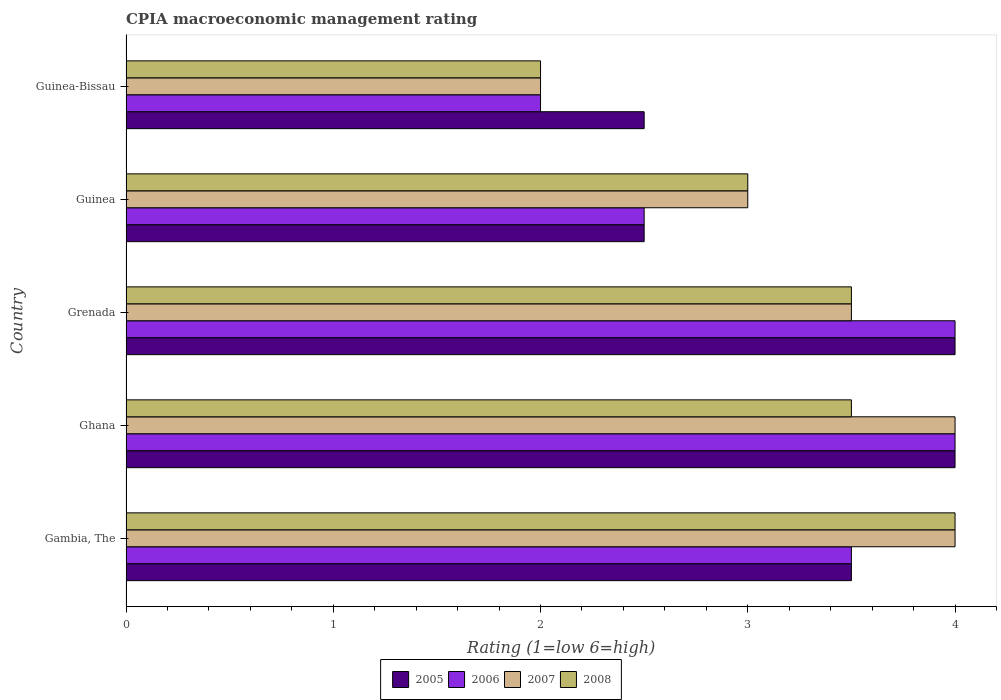How many groups of bars are there?
Give a very brief answer. 5. How many bars are there on the 4th tick from the top?
Your response must be concise. 4. What is the label of the 2nd group of bars from the top?
Give a very brief answer. Guinea. Across all countries, what is the maximum CPIA rating in 2008?
Keep it short and to the point. 4. In which country was the CPIA rating in 2005 minimum?
Ensure brevity in your answer.  Guinea. What is the total CPIA rating in 2005 in the graph?
Provide a succinct answer. 16.5. What is the difference between the CPIA rating in 2005 in Gambia, The and that in Grenada?
Your answer should be compact. -0.5. What is the difference between the CPIA rating in 2005 in Guinea and the CPIA rating in 2007 in Grenada?
Make the answer very short. -1. What is the average CPIA rating in 2006 per country?
Provide a succinct answer. 3.2. What is the difference between the CPIA rating in 2005 and CPIA rating in 2007 in Guinea-Bissau?
Provide a succinct answer. 0.5. What is the ratio of the CPIA rating in 2005 in Ghana to that in Guinea-Bissau?
Ensure brevity in your answer.  1.6. Is the difference between the CPIA rating in 2005 in Gambia, The and Guinea greater than the difference between the CPIA rating in 2007 in Gambia, The and Guinea?
Offer a terse response. No. What does the 2nd bar from the bottom in Ghana represents?
Your response must be concise. 2006. Is it the case that in every country, the sum of the CPIA rating in 2005 and CPIA rating in 2008 is greater than the CPIA rating in 2006?
Make the answer very short. Yes. Are the values on the major ticks of X-axis written in scientific E-notation?
Your response must be concise. No. Does the graph contain any zero values?
Your answer should be compact. No. Does the graph contain grids?
Provide a succinct answer. No. Where does the legend appear in the graph?
Your response must be concise. Bottom center. How many legend labels are there?
Provide a short and direct response. 4. How are the legend labels stacked?
Your answer should be very brief. Horizontal. What is the title of the graph?
Your answer should be compact. CPIA macroeconomic management rating. What is the label or title of the X-axis?
Your response must be concise. Rating (1=low 6=high). What is the label or title of the Y-axis?
Your response must be concise. Country. What is the Rating (1=low 6=high) in 2005 in Gambia, The?
Offer a very short reply. 3.5. What is the Rating (1=low 6=high) in 2005 in Ghana?
Provide a succinct answer. 4. What is the Rating (1=low 6=high) of 2006 in Ghana?
Make the answer very short. 4. What is the Rating (1=low 6=high) of 2007 in Ghana?
Provide a short and direct response. 4. What is the Rating (1=low 6=high) in 2008 in Ghana?
Keep it short and to the point. 3.5. What is the Rating (1=low 6=high) of 2008 in Grenada?
Offer a terse response. 3.5. What is the Rating (1=low 6=high) of 2005 in Guinea?
Provide a short and direct response. 2.5. What is the Rating (1=low 6=high) in 2006 in Guinea?
Give a very brief answer. 2.5. What is the Rating (1=low 6=high) of 2008 in Guinea?
Keep it short and to the point. 3. What is the Rating (1=low 6=high) of 2008 in Guinea-Bissau?
Give a very brief answer. 2. Across all countries, what is the maximum Rating (1=low 6=high) in 2005?
Provide a succinct answer. 4. Across all countries, what is the maximum Rating (1=low 6=high) of 2006?
Keep it short and to the point. 4. Across all countries, what is the maximum Rating (1=low 6=high) in 2007?
Make the answer very short. 4. Across all countries, what is the maximum Rating (1=low 6=high) of 2008?
Your response must be concise. 4. Across all countries, what is the minimum Rating (1=low 6=high) of 2005?
Ensure brevity in your answer.  2.5. Across all countries, what is the minimum Rating (1=low 6=high) in 2008?
Provide a succinct answer. 2. What is the total Rating (1=low 6=high) of 2007 in the graph?
Your response must be concise. 16.5. What is the total Rating (1=low 6=high) of 2008 in the graph?
Offer a very short reply. 16. What is the difference between the Rating (1=low 6=high) in 2005 in Gambia, The and that in Ghana?
Your answer should be compact. -0.5. What is the difference between the Rating (1=low 6=high) of 2006 in Gambia, The and that in Ghana?
Provide a short and direct response. -0.5. What is the difference between the Rating (1=low 6=high) of 2008 in Gambia, The and that in Ghana?
Your answer should be very brief. 0.5. What is the difference between the Rating (1=low 6=high) of 2005 in Gambia, The and that in Grenada?
Your answer should be very brief. -0.5. What is the difference between the Rating (1=low 6=high) in 2008 in Gambia, The and that in Guinea?
Provide a short and direct response. 1. What is the difference between the Rating (1=low 6=high) of 2005 in Gambia, The and that in Guinea-Bissau?
Make the answer very short. 1. What is the difference between the Rating (1=low 6=high) in 2007 in Gambia, The and that in Guinea-Bissau?
Your response must be concise. 2. What is the difference between the Rating (1=low 6=high) in 2005 in Ghana and that in Guinea?
Your answer should be compact. 1.5. What is the difference between the Rating (1=low 6=high) in 2006 in Ghana and that in Guinea-Bissau?
Give a very brief answer. 2. What is the difference between the Rating (1=low 6=high) in 2005 in Grenada and that in Guinea?
Provide a short and direct response. 1.5. What is the difference between the Rating (1=low 6=high) of 2005 in Guinea and that in Guinea-Bissau?
Provide a short and direct response. 0. What is the difference between the Rating (1=low 6=high) in 2008 in Guinea and that in Guinea-Bissau?
Give a very brief answer. 1. What is the difference between the Rating (1=low 6=high) of 2005 in Gambia, The and the Rating (1=low 6=high) of 2008 in Ghana?
Give a very brief answer. 0. What is the difference between the Rating (1=low 6=high) in 2007 in Gambia, The and the Rating (1=low 6=high) in 2008 in Ghana?
Provide a short and direct response. 0.5. What is the difference between the Rating (1=low 6=high) in 2005 in Gambia, The and the Rating (1=low 6=high) in 2006 in Grenada?
Give a very brief answer. -0.5. What is the difference between the Rating (1=low 6=high) of 2006 in Gambia, The and the Rating (1=low 6=high) of 2007 in Grenada?
Your answer should be compact. 0. What is the difference between the Rating (1=low 6=high) of 2006 in Gambia, The and the Rating (1=low 6=high) of 2008 in Grenada?
Keep it short and to the point. 0. What is the difference between the Rating (1=low 6=high) in 2005 in Gambia, The and the Rating (1=low 6=high) in 2006 in Guinea?
Offer a very short reply. 1. What is the difference between the Rating (1=low 6=high) of 2005 in Gambia, The and the Rating (1=low 6=high) of 2008 in Guinea?
Make the answer very short. 0.5. What is the difference between the Rating (1=low 6=high) in 2005 in Gambia, The and the Rating (1=low 6=high) in 2007 in Guinea-Bissau?
Your response must be concise. 1.5. What is the difference between the Rating (1=low 6=high) of 2005 in Gambia, The and the Rating (1=low 6=high) of 2008 in Guinea-Bissau?
Keep it short and to the point. 1.5. What is the difference between the Rating (1=low 6=high) in 2006 in Gambia, The and the Rating (1=low 6=high) in 2007 in Guinea-Bissau?
Provide a succinct answer. 1.5. What is the difference between the Rating (1=low 6=high) of 2006 in Gambia, The and the Rating (1=low 6=high) of 2008 in Guinea-Bissau?
Provide a succinct answer. 1.5. What is the difference between the Rating (1=low 6=high) in 2007 in Gambia, The and the Rating (1=low 6=high) in 2008 in Guinea-Bissau?
Keep it short and to the point. 2. What is the difference between the Rating (1=low 6=high) of 2005 in Ghana and the Rating (1=low 6=high) of 2006 in Grenada?
Offer a very short reply. 0. What is the difference between the Rating (1=low 6=high) in 2005 in Ghana and the Rating (1=low 6=high) in 2008 in Grenada?
Your answer should be very brief. 0.5. What is the difference between the Rating (1=low 6=high) in 2006 in Ghana and the Rating (1=low 6=high) in 2007 in Grenada?
Make the answer very short. 0.5. What is the difference between the Rating (1=low 6=high) of 2006 in Ghana and the Rating (1=low 6=high) of 2008 in Grenada?
Give a very brief answer. 0.5. What is the difference between the Rating (1=low 6=high) of 2007 in Ghana and the Rating (1=low 6=high) of 2008 in Grenada?
Offer a terse response. 0.5. What is the difference between the Rating (1=low 6=high) in 2006 in Ghana and the Rating (1=low 6=high) in 2007 in Guinea?
Offer a terse response. 1. What is the difference between the Rating (1=low 6=high) of 2005 in Ghana and the Rating (1=low 6=high) of 2006 in Guinea-Bissau?
Your answer should be compact. 2. What is the difference between the Rating (1=low 6=high) in 2005 in Ghana and the Rating (1=low 6=high) in 2008 in Guinea-Bissau?
Ensure brevity in your answer.  2. What is the difference between the Rating (1=low 6=high) of 2006 in Ghana and the Rating (1=low 6=high) of 2007 in Guinea-Bissau?
Give a very brief answer. 2. What is the difference between the Rating (1=low 6=high) in 2006 in Ghana and the Rating (1=low 6=high) in 2008 in Guinea-Bissau?
Keep it short and to the point. 2. What is the difference between the Rating (1=low 6=high) in 2007 in Ghana and the Rating (1=low 6=high) in 2008 in Guinea-Bissau?
Your answer should be compact. 2. What is the difference between the Rating (1=low 6=high) of 2005 in Grenada and the Rating (1=low 6=high) of 2006 in Guinea?
Your answer should be compact. 1.5. What is the difference between the Rating (1=low 6=high) of 2005 in Grenada and the Rating (1=low 6=high) of 2007 in Guinea?
Your answer should be compact. 1. What is the difference between the Rating (1=low 6=high) in 2007 in Grenada and the Rating (1=low 6=high) in 2008 in Guinea?
Your answer should be compact. 0.5. What is the difference between the Rating (1=low 6=high) in 2005 in Grenada and the Rating (1=low 6=high) in 2006 in Guinea-Bissau?
Your response must be concise. 2. What is the difference between the Rating (1=low 6=high) in 2005 in Grenada and the Rating (1=low 6=high) in 2007 in Guinea-Bissau?
Your answer should be compact. 2. What is the difference between the Rating (1=low 6=high) in 2005 in Grenada and the Rating (1=low 6=high) in 2008 in Guinea-Bissau?
Your answer should be compact. 2. What is the difference between the Rating (1=low 6=high) of 2006 in Grenada and the Rating (1=low 6=high) of 2007 in Guinea-Bissau?
Your response must be concise. 2. What is the difference between the Rating (1=low 6=high) in 2007 in Grenada and the Rating (1=low 6=high) in 2008 in Guinea-Bissau?
Your answer should be very brief. 1.5. What is the difference between the Rating (1=low 6=high) of 2005 in Guinea and the Rating (1=low 6=high) of 2006 in Guinea-Bissau?
Ensure brevity in your answer.  0.5. What is the difference between the Rating (1=low 6=high) in 2005 in Guinea and the Rating (1=low 6=high) in 2007 in Guinea-Bissau?
Give a very brief answer. 0.5. What is the difference between the Rating (1=low 6=high) in 2005 in Guinea and the Rating (1=low 6=high) in 2008 in Guinea-Bissau?
Your answer should be very brief. 0.5. What is the difference between the Rating (1=low 6=high) in 2006 in Guinea and the Rating (1=low 6=high) in 2007 in Guinea-Bissau?
Your answer should be very brief. 0.5. What is the difference between the Rating (1=low 6=high) of 2007 in Guinea and the Rating (1=low 6=high) of 2008 in Guinea-Bissau?
Provide a succinct answer. 1. What is the average Rating (1=low 6=high) in 2005 per country?
Make the answer very short. 3.3. What is the average Rating (1=low 6=high) in 2006 per country?
Your response must be concise. 3.2. What is the average Rating (1=low 6=high) in 2007 per country?
Offer a very short reply. 3.3. What is the difference between the Rating (1=low 6=high) of 2005 and Rating (1=low 6=high) of 2008 in Gambia, The?
Offer a very short reply. -0.5. What is the difference between the Rating (1=low 6=high) of 2006 and Rating (1=low 6=high) of 2008 in Gambia, The?
Provide a short and direct response. -0.5. What is the difference between the Rating (1=low 6=high) of 2007 and Rating (1=low 6=high) of 2008 in Gambia, The?
Keep it short and to the point. 0. What is the difference between the Rating (1=low 6=high) of 2005 and Rating (1=low 6=high) of 2007 in Ghana?
Your answer should be compact. 0. What is the difference between the Rating (1=low 6=high) in 2006 and Rating (1=low 6=high) in 2007 in Ghana?
Make the answer very short. 0. What is the difference between the Rating (1=low 6=high) in 2006 and Rating (1=low 6=high) in 2008 in Ghana?
Ensure brevity in your answer.  0.5. What is the difference between the Rating (1=low 6=high) of 2005 and Rating (1=low 6=high) of 2008 in Grenada?
Offer a terse response. 0.5. What is the difference between the Rating (1=low 6=high) of 2006 and Rating (1=low 6=high) of 2008 in Grenada?
Make the answer very short. 0.5. What is the difference between the Rating (1=low 6=high) of 2005 and Rating (1=low 6=high) of 2007 in Guinea?
Offer a very short reply. -0.5. What is the difference between the Rating (1=low 6=high) in 2006 and Rating (1=low 6=high) in 2008 in Guinea?
Offer a very short reply. -0.5. What is the difference between the Rating (1=low 6=high) in 2007 and Rating (1=low 6=high) in 2008 in Guinea?
Keep it short and to the point. 0. What is the difference between the Rating (1=low 6=high) in 2005 and Rating (1=low 6=high) in 2006 in Guinea-Bissau?
Provide a short and direct response. 0.5. What is the difference between the Rating (1=low 6=high) in 2006 and Rating (1=low 6=high) in 2007 in Guinea-Bissau?
Make the answer very short. 0. What is the ratio of the Rating (1=low 6=high) in 2006 in Gambia, The to that in Ghana?
Ensure brevity in your answer.  0.88. What is the ratio of the Rating (1=low 6=high) in 2007 in Gambia, The to that in Ghana?
Your response must be concise. 1. What is the ratio of the Rating (1=low 6=high) in 2008 in Gambia, The to that in Ghana?
Offer a very short reply. 1.14. What is the ratio of the Rating (1=low 6=high) of 2007 in Gambia, The to that in Grenada?
Give a very brief answer. 1.14. What is the ratio of the Rating (1=low 6=high) in 2005 in Gambia, The to that in Guinea?
Keep it short and to the point. 1.4. What is the ratio of the Rating (1=low 6=high) in 2005 in Gambia, The to that in Guinea-Bissau?
Give a very brief answer. 1.4. What is the ratio of the Rating (1=low 6=high) of 2007 in Gambia, The to that in Guinea-Bissau?
Keep it short and to the point. 2. What is the ratio of the Rating (1=low 6=high) in 2008 in Gambia, The to that in Guinea-Bissau?
Ensure brevity in your answer.  2. What is the ratio of the Rating (1=low 6=high) in 2005 in Ghana to that in Grenada?
Ensure brevity in your answer.  1. What is the ratio of the Rating (1=low 6=high) in 2007 in Ghana to that in Grenada?
Offer a terse response. 1.14. What is the ratio of the Rating (1=low 6=high) in 2006 in Ghana to that in Guinea?
Keep it short and to the point. 1.6. What is the ratio of the Rating (1=low 6=high) of 2007 in Ghana to that in Guinea?
Your response must be concise. 1.33. What is the ratio of the Rating (1=low 6=high) in 2006 in Ghana to that in Guinea-Bissau?
Your answer should be very brief. 2. What is the ratio of the Rating (1=low 6=high) of 2008 in Ghana to that in Guinea-Bissau?
Offer a terse response. 1.75. What is the ratio of the Rating (1=low 6=high) in 2008 in Grenada to that in Guinea?
Your answer should be very brief. 1.17. What is the ratio of the Rating (1=low 6=high) in 2005 in Grenada to that in Guinea-Bissau?
Ensure brevity in your answer.  1.6. What is the ratio of the Rating (1=low 6=high) in 2007 in Grenada to that in Guinea-Bissau?
Ensure brevity in your answer.  1.75. What is the ratio of the Rating (1=low 6=high) in 2008 in Grenada to that in Guinea-Bissau?
Your answer should be compact. 1.75. What is the ratio of the Rating (1=low 6=high) in 2007 in Guinea to that in Guinea-Bissau?
Offer a terse response. 1.5. What is the difference between the highest and the second highest Rating (1=low 6=high) of 2006?
Ensure brevity in your answer.  0. What is the difference between the highest and the lowest Rating (1=low 6=high) of 2008?
Keep it short and to the point. 2. 